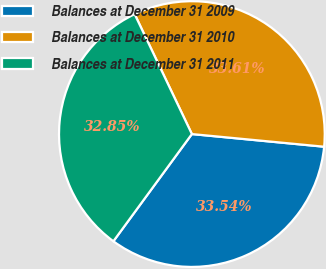Convert chart to OTSL. <chart><loc_0><loc_0><loc_500><loc_500><pie_chart><fcel>Balances at December 31 2009<fcel>Balances at December 31 2010<fcel>Balances at December 31 2011<nl><fcel>33.54%<fcel>33.61%<fcel>32.85%<nl></chart> 